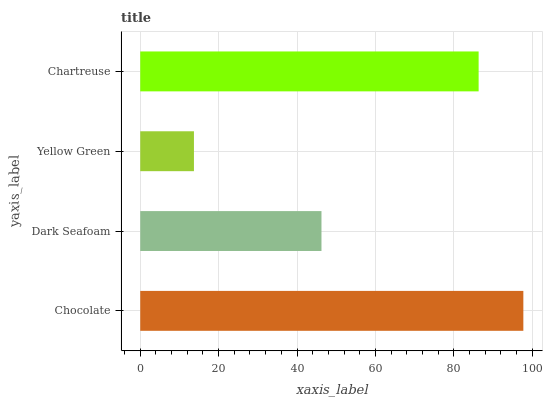Is Yellow Green the minimum?
Answer yes or no. Yes. Is Chocolate the maximum?
Answer yes or no. Yes. Is Dark Seafoam the minimum?
Answer yes or no. No. Is Dark Seafoam the maximum?
Answer yes or no. No. Is Chocolate greater than Dark Seafoam?
Answer yes or no. Yes. Is Dark Seafoam less than Chocolate?
Answer yes or no. Yes. Is Dark Seafoam greater than Chocolate?
Answer yes or no. No. Is Chocolate less than Dark Seafoam?
Answer yes or no. No. Is Chartreuse the high median?
Answer yes or no. Yes. Is Dark Seafoam the low median?
Answer yes or no. Yes. Is Chocolate the high median?
Answer yes or no. No. Is Yellow Green the low median?
Answer yes or no. No. 